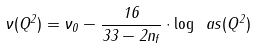Convert formula to latex. <formula><loc_0><loc_0><loc_500><loc_500>\nu ( Q ^ { 2 } ) = \nu _ { 0 } - \frac { 1 6 } { 3 3 - 2 n _ { f } } \cdot \log \ a s ( Q ^ { 2 } )</formula> 